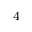<formula> <loc_0><loc_0><loc_500><loc_500>^ { 4 }</formula> 